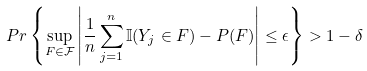Convert formula to latex. <formula><loc_0><loc_0><loc_500><loc_500>P r \left \{ \sup _ { F \in \mathcal { F } } \left | \frac { 1 } { n } \sum _ { j = 1 } ^ { n } \mathbb { I } ( Y _ { j } \in F ) - P ( F ) \right | \leq \epsilon \right \} > 1 - \delta</formula> 